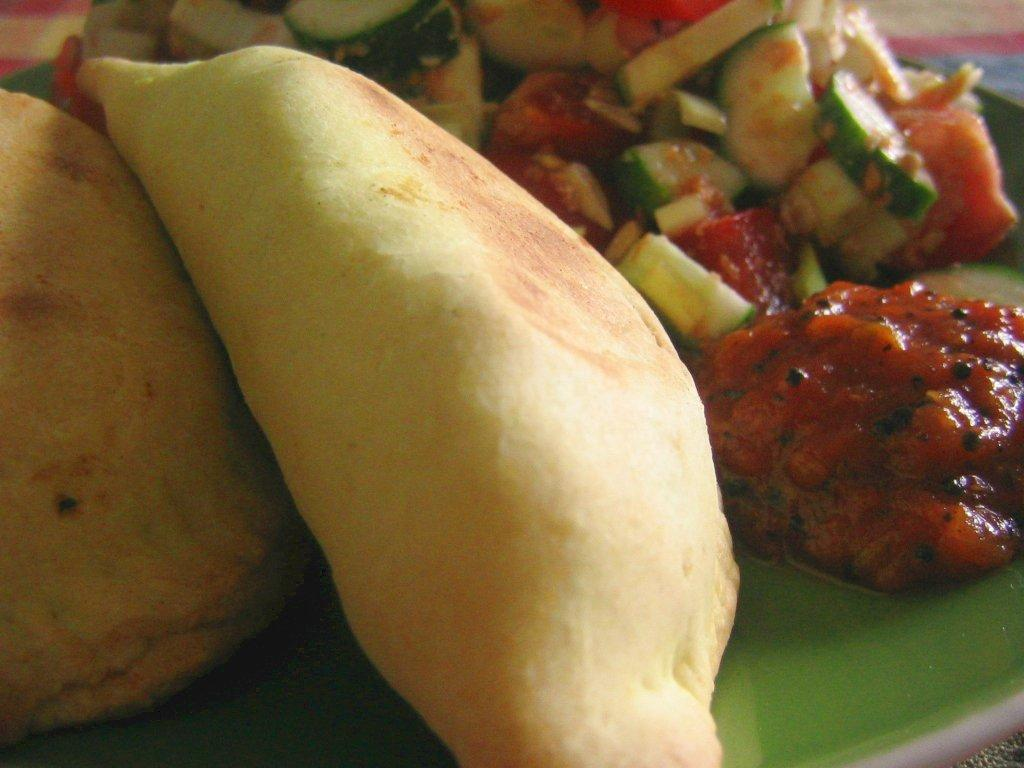What is present on the plate in the image? There is food in a plate in the image. What type of mountain can be seen in the background of the image? There is no mountain present in the image; it only features a plate of food. 